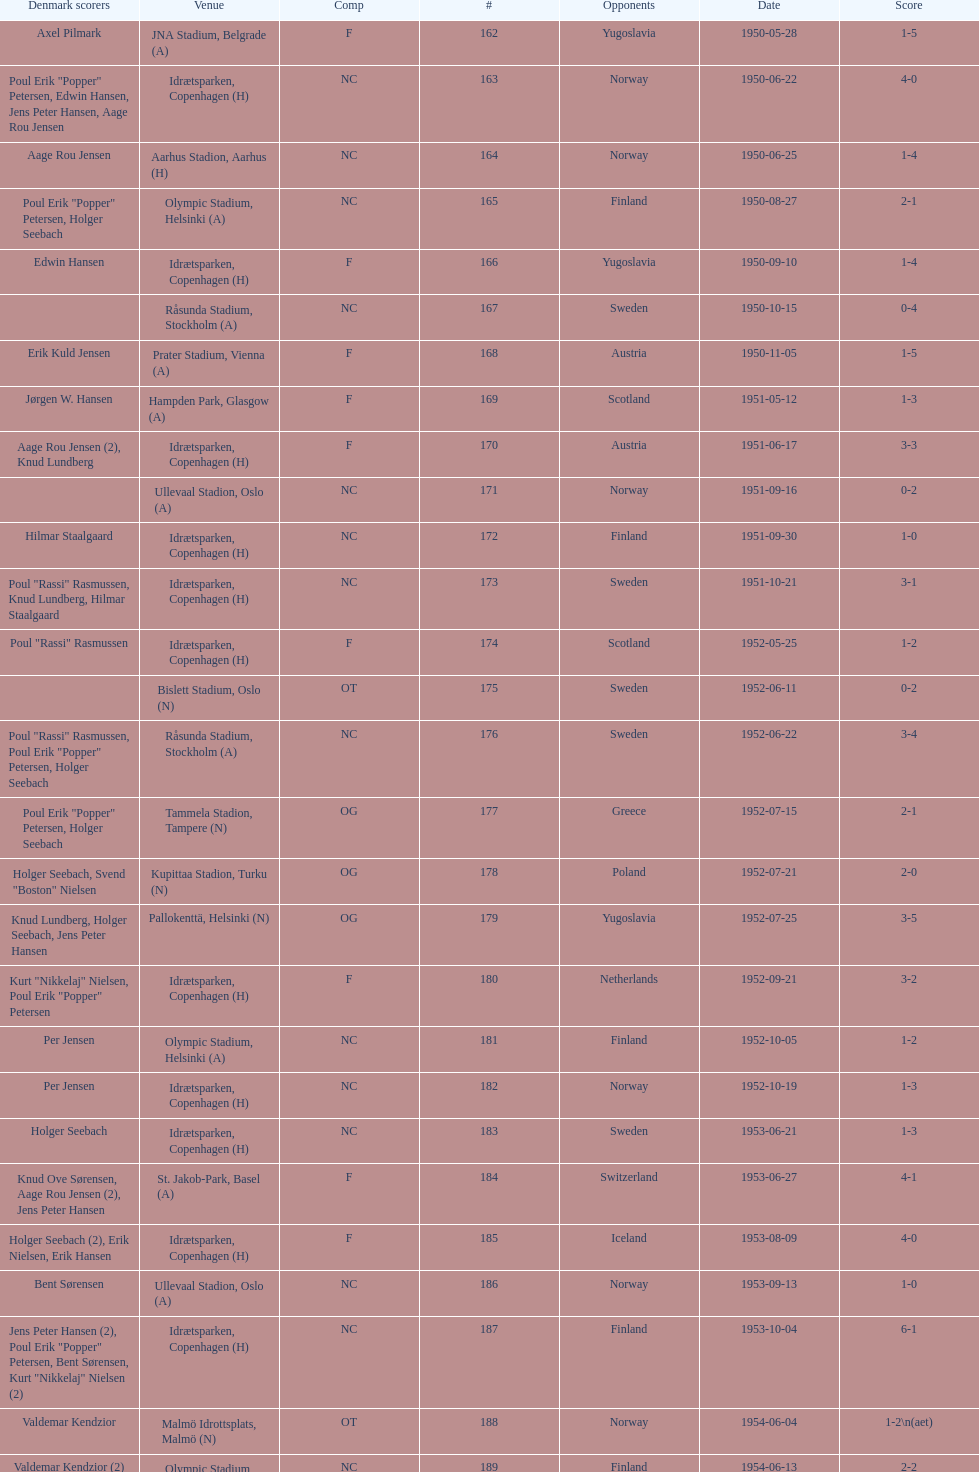When was the last time the team went 0-6? 1959-06-21. 